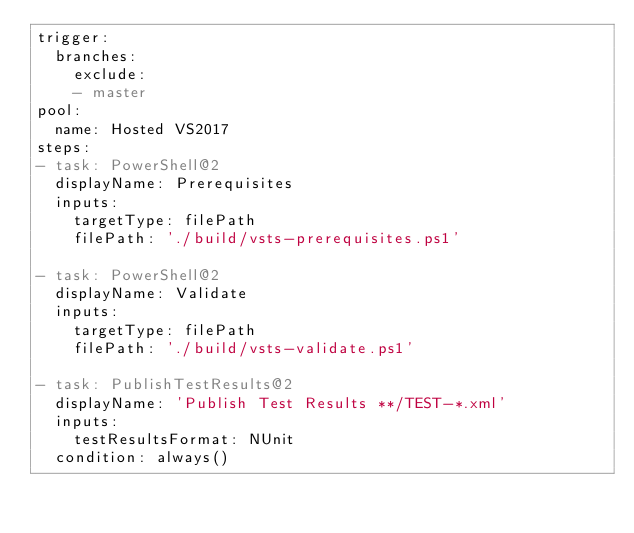<code> <loc_0><loc_0><loc_500><loc_500><_YAML_>trigger:
  branches:
    exclude:
    - master
pool:
  name: Hosted VS2017
steps:
- task: PowerShell@2
  displayName: Prerequisites
  inputs:
    targetType: filePath
    filePath: './build/vsts-prerequisites.ps1'

- task: PowerShell@2
  displayName: Validate
  inputs:
    targetType: filePath
    filePath: './build/vsts-validate.ps1'

- task: PublishTestResults@2
  displayName: 'Publish Test Results **/TEST-*.xml'
  inputs:
    testResultsFormat: NUnit
  condition: always()</code> 